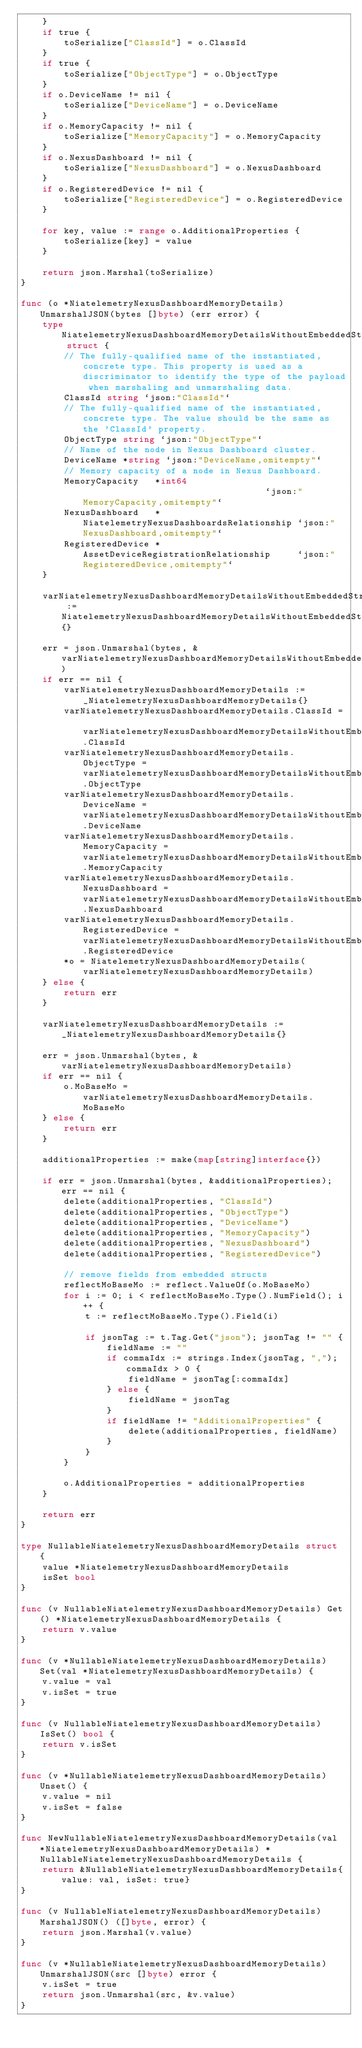<code> <loc_0><loc_0><loc_500><loc_500><_Go_>	}
	if true {
		toSerialize["ClassId"] = o.ClassId
	}
	if true {
		toSerialize["ObjectType"] = o.ObjectType
	}
	if o.DeviceName != nil {
		toSerialize["DeviceName"] = o.DeviceName
	}
	if o.MemoryCapacity != nil {
		toSerialize["MemoryCapacity"] = o.MemoryCapacity
	}
	if o.NexusDashboard != nil {
		toSerialize["NexusDashboard"] = o.NexusDashboard
	}
	if o.RegisteredDevice != nil {
		toSerialize["RegisteredDevice"] = o.RegisteredDevice
	}

	for key, value := range o.AdditionalProperties {
		toSerialize[key] = value
	}

	return json.Marshal(toSerialize)
}

func (o *NiatelemetryNexusDashboardMemoryDetails) UnmarshalJSON(bytes []byte) (err error) {
	type NiatelemetryNexusDashboardMemoryDetailsWithoutEmbeddedStruct struct {
		// The fully-qualified name of the instantiated, concrete type. This property is used as a discriminator to identify the type of the payload when marshaling and unmarshaling data.
		ClassId string `json:"ClassId"`
		// The fully-qualified name of the instantiated, concrete type. The value should be the same as the 'ClassId' property.
		ObjectType string `json:"ObjectType"`
		// Name of the node in Nexus Dashboard cluster.
		DeviceName *string `json:"DeviceName,omitempty"`
		// Memory capacity of a node in Nexus Dashboard.
		MemoryCapacity   *int64                                   `json:"MemoryCapacity,omitempty"`
		NexusDashboard   *NiatelemetryNexusDashboardsRelationship `json:"NexusDashboard,omitempty"`
		RegisteredDevice *AssetDeviceRegistrationRelationship     `json:"RegisteredDevice,omitempty"`
	}

	varNiatelemetryNexusDashboardMemoryDetailsWithoutEmbeddedStruct := NiatelemetryNexusDashboardMemoryDetailsWithoutEmbeddedStruct{}

	err = json.Unmarshal(bytes, &varNiatelemetryNexusDashboardMemoryDetailsWithoutEmbeddedStruct)
	if err == nil {
		varNiatelemetryNexusDashboardMemoryDetails := _NiatelemetryNexusDashboardMemoryDetails{}
		varNiatelemetryNexusDashboardMemoryDetails.ClassId = varNiatelemetryNexusDashboardMemoryDetailsWithoutEmbeddedStruct.ClassId
		varNiatelemetryNexusDashboardMemoryDetails.ObjectType = varNiatelemetryNexusDashboardMemoryDetailsWithoutEmbeddedStruct.ObjectType
		varNiatelemetryNexusDashboardMemoryDetails.DeviceName = varNiatelemetryNexusDashboardMemoryDetailsWithoutEmbeddedStruct.DeviceName
		varNiatelemetryNexusDashboardMemoryDetails.MemoryCapacity = varNiatelemetryNexusDashboardMemoryDetailsWithoutEmbeddedStruct.MemoryCapacity
		varNiatelemetryNexusDashboardMemoryDetails.NexusDashboard = varNiatelemetryNexusDashboardMemoryDetailsWithoutEmbeddedStruct.NexusDashboard
		varNiatelemetryNexusDashboardMemoryDetails.RegisteredDevice = varNiatelemetryNexusDashboardMemoryDetailsWithoutEmbeddedStruct.RegisteredDevice
		*o = NiatelemetryNexusDashboardMemoryDetails(varNiatelemetryNexusDashboardMemoryDetails)
	} else {
		return err
	}

	varNiatelemetryNexusDashboardMemoryDetails := _NiatelemetryNexusDashboardMemoryDetails{}

	err = json.Unmarshal(bytes, &varNiatelemetryNexusDashboardMemoryDetails)
	if err == nil {
		o.MoBaseMo = varNiatelemetryNexusDashboardMemoryDetails.MoBaseMo
	} else {
		return err
	}

	additionalProperties := make(map[string]interface{})

	if err = json.Unmarshal(bytes, &additionalProperties); err == nil {
		delete(additionalProperties, "ClassId")
		delete(additionalProperties, "ObjectType")
		delete(additionalProperties, "DeviceName")
		delete(additionalProperties, "MemoryCapacity")
		delete(additionalProperties, "NexusDashboard")
		delete(additionalProperties, "RegisteredDevice")

		// remove fields from embedded structs
		reflectMoBaseMo := reflect.ValueOf(o.MoBaseMo)
		for i := 0; i < reflectMoBaseMo.Type().NumField(); i++ {
			t := reflectMoBaseMo.Type().Field(i)

			if jsonTag := t.Tag.Get("json"); jsonTag != "" {
				fieldName := ""
				if commaIdx := strings.Index(jsonTag, ","); commaIdx > 0 {
					fieldName = jsonTag[:commaIdx]
				} else {
					fieldName = jsonTag
				}
				if fieldName != "AdditionalProperties" {
					delete(additionalProperties, fieldName)
				}
			}
		}

		o.AdditionalProperties = additionalProperties
	}

	return err
}

type NullableNiatelemetryNexusDashboardMemoryDetails struct {
	value *NiatelemetryNexusDashboardMemoryDetails
	isSet bool
}

func (v NullableNiatelemetryNexusDashboardMemoryDetails) Get() *NiatelemetryNexusDashboardMemoryDetails {
	return v.value
}

func (v *NullableNiatelemetryNexusDashboardMemoryDetails) Set(val *NiatelemetryNexusDashboardMemoryDetails) {
	v.value = val
	v.isSet = true
}

func (v NullableNiatelemetryNexusDashboardMemoryDetails) IsSet() bool {
	return v.isSet
}

func (v *NullableNiatelemetryNexusDashboardMemoryDetails) Unset() {
	v.value = nil
	v.isSet = false
}

func NewNullableNiatelemetryNexusDashboardMemoryDetails(val *NiatelemetryNexusDashboardMemoryDetails) *NullableNiatelemetryNexusDashboardMemoryDetails {
	return &NullableNiatelemetryNexusDashboardMemoryDetails{value: val, isSet: true}
}

func (v NullableNiatelemetryNexusDashboardMemoryDetails) MarshalJSON() ([]byte, error) {
	return json.Marshal(v.value)
}

func (v *NullableNiatelemetryNexusDashboardMemoryDetails) UnmarshalJSON(src []byte) error {
	v.isSet = true
	return json.Unmarshal(src, &v.value)
}
</code> 